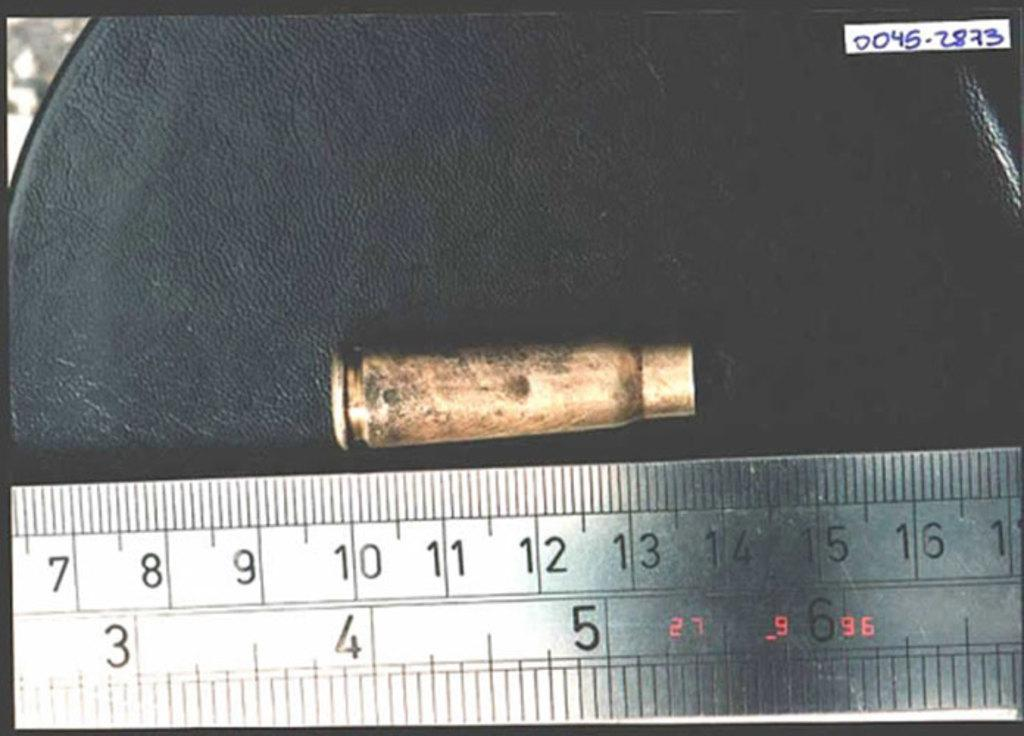<image>
Offer a succinct explanation of the picture presented. A white ruler measuring a yellowish object with the text 0045-2873 in the upper right. 